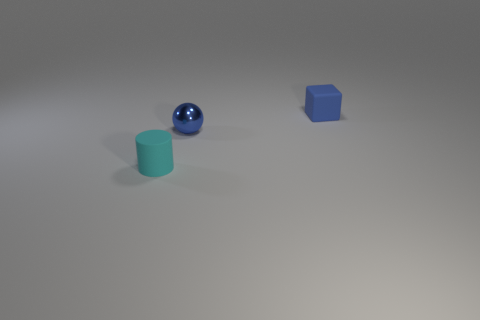Add 2 small shiny things. How many objects exist? 5 Subtract all cylinders. How many objects are left? 2 Subtract all tiny cubes. Subtract all balls. How many objects are left? 1 Add 1 blue shiny spheres. How many blue shiny spheres are left? 2 Add 3 yellow rubber cylinders. How many yellow rubber cylinders exist? 3 Subtract 0 yellow cylinders. How many objects are left? 3 